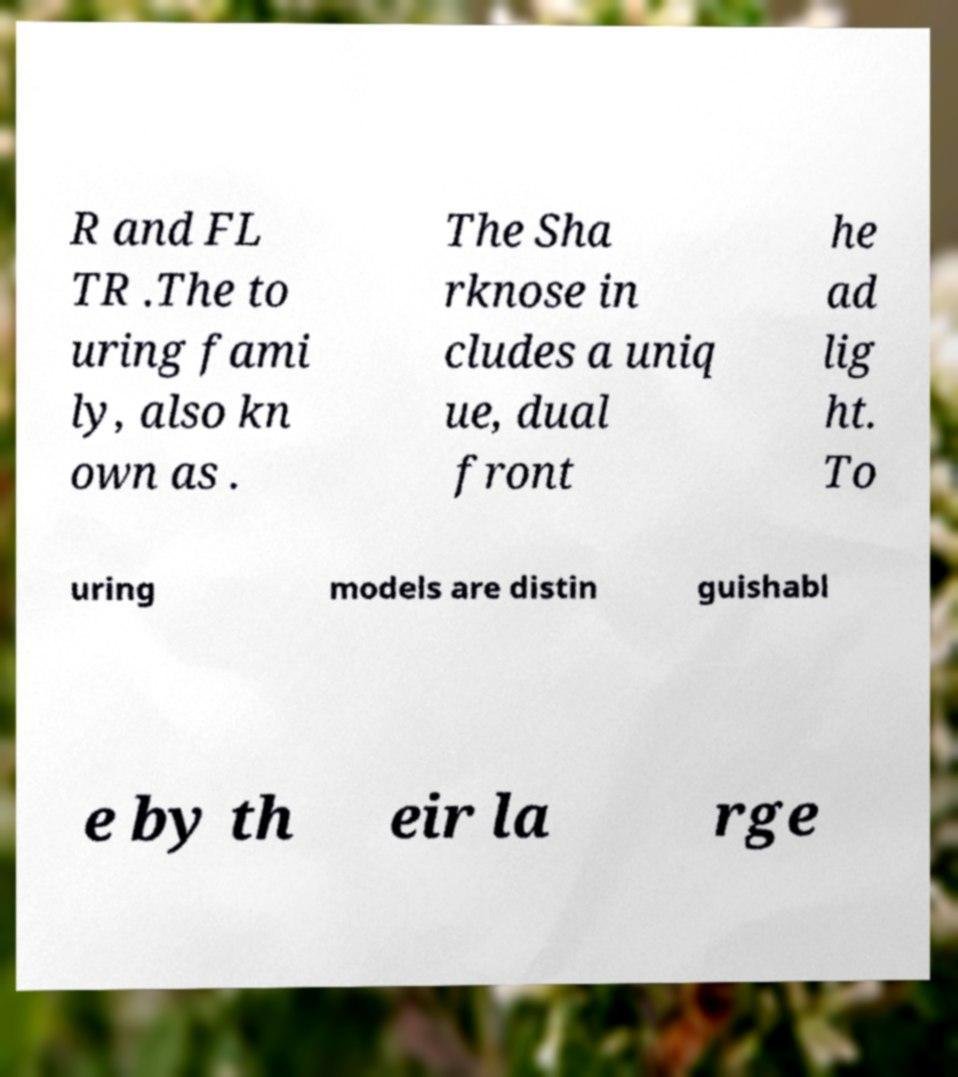Can you read and provide the text displayed in the image?This photo seems to have some interesting text. Can you extract and type it out for me? R and FL TR .The to uring fami ly, also kn own as . The Sha rknose in cludes a uniq ue, dual front he ad lig ht. To uring models are distin guishabl e by th eir la rge 